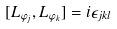Convert formula to latex. <formula><loc_0><loc_0><loc_500><loc_500>[ L _ { \varphi _ { j } } , L _ { \varphi _ { k } } ] = i \epsilon _ { j k l }</formula> 